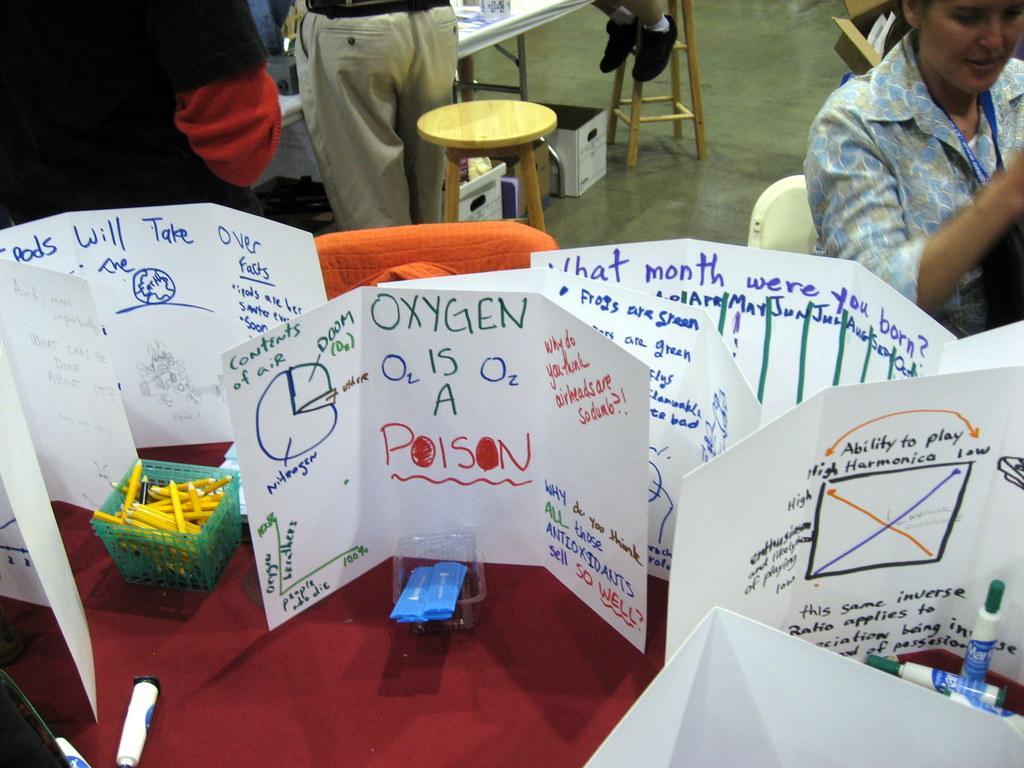Can you describe this image briefly? In this image i can see few charts,glasses,and pencils on the table at the back ground the women is sitting wearing a badge, and two persons standing,a chair, and at the ground i can see a cart board and a person sitting on the chair. 